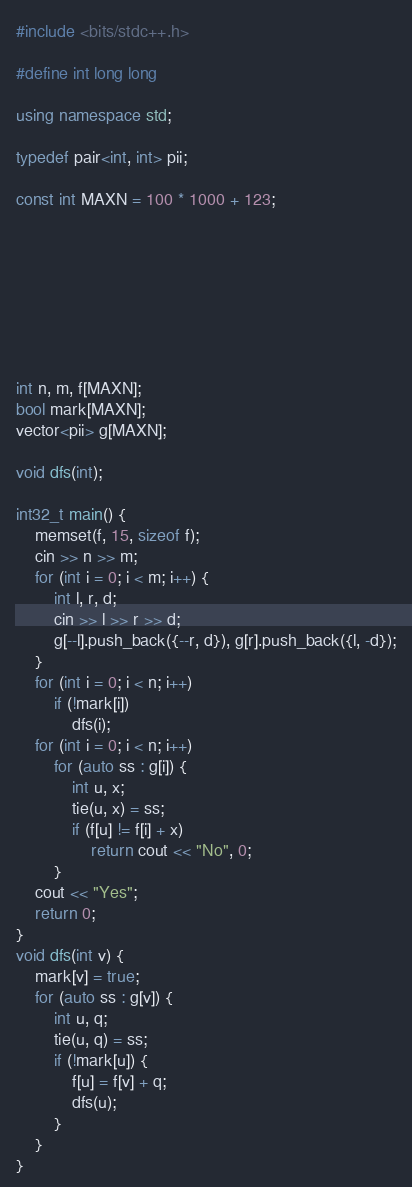<code> <loc_0><loc_0><loc_500><loc_500><_C++_>#include <bits/stdc++.h>

#define int long long

using namespace std;

typedef pair<int, int> pii;

const int MAXN = 100 * 1000 + 123;








int n, m, f[MAXN];
bool mark[MAXN];
vector<pii> g[MAXN];

void dfs(int);

int32_t main() {
    memset(f, 15, sizeof f);
    cin >> n >> m;
    for (int i = 0; i < m; i++) {
        int l, r, d;
        cin >> l >> r >> d;
        g[--l].push_back({--r, d}), g[r].push_back({l, -d});
    }
    for (int i = 0; i < n; i++)
        if (!mark[i])
            dfs(i);
    for (int i = 0; i < n; i++)
        for (auto ss : g[i]) {
            int u, x;
            tie(u, x) = ss;
            if (f[u] != f[i] + x)
                return cout << "No", 0;
        }
    cout << "Yes";
    return 0;
}
void dfs(int v) {
    mark[v] = true;
    for (auto ss : g[v]) {
        int u, q;
        tie(u, q) = ss;
        if (!mark[u]) {
            f[u] = f[v] + q;
            dfs(u);
        }
    }
}</code> 